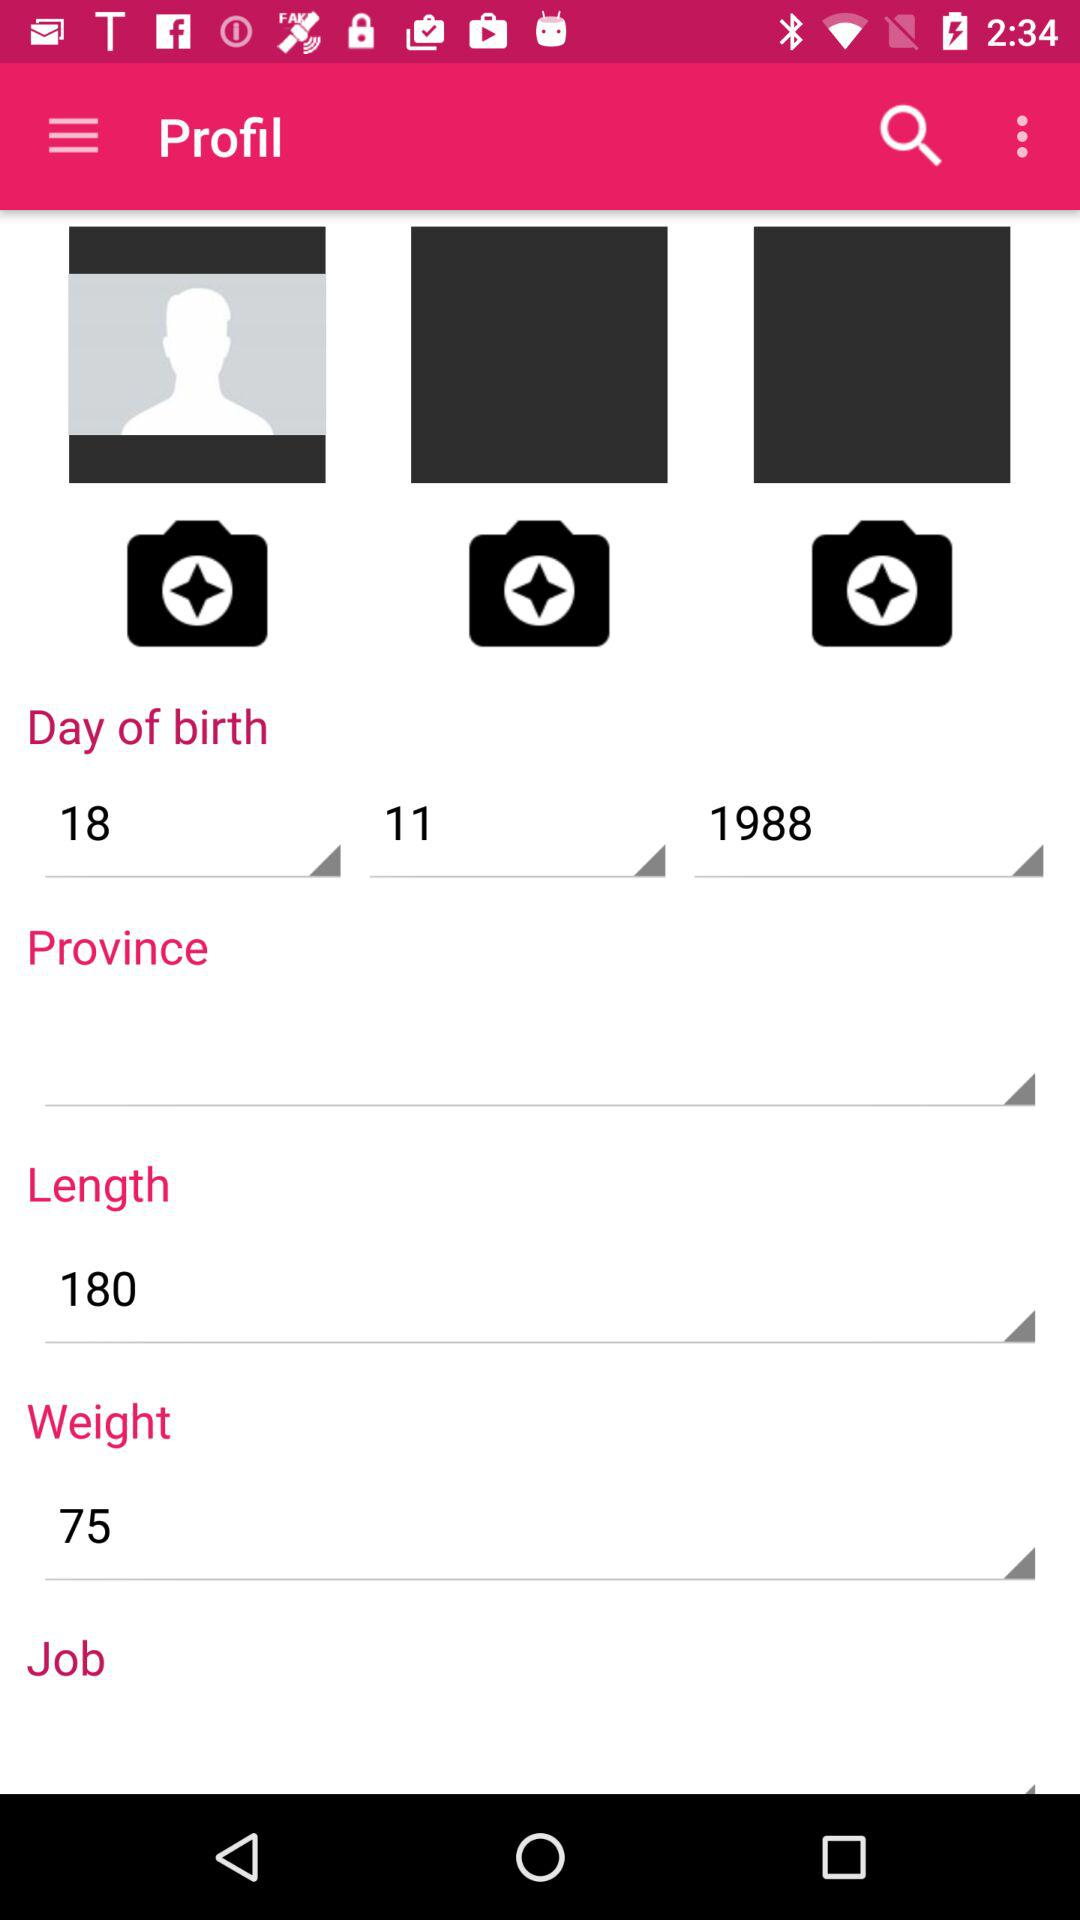What is the date of birth selected in the profile? The date of birth selected in the profile is November 18, 1988. 